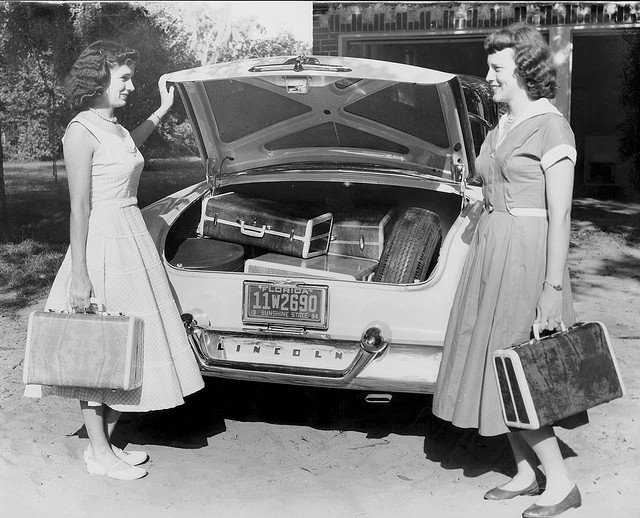Describe the objects in this image and their specific colors. I can see car in gray, black, lightgray, and darkgray tones, people in gray, darkgray, lightgray, and black tones, people in gray, lightgray, darkgray, and black tones, suitcase in gray, black, lightgray, and darkgray tones, and suitcase in gray, darkgray, lightgray, and black tones in this image. 